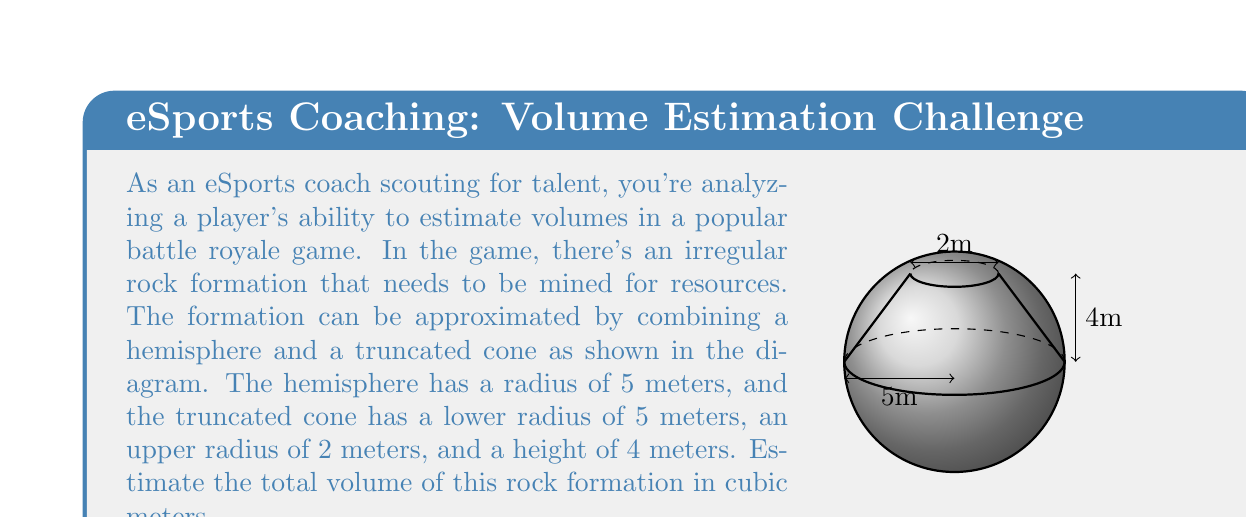Can you answer this question? To estimate the total volume of the rock formation, we need to calculate the volumes of the hemisphere and the truncated cone separately, then add them together.

1. Volume of the hemisphere:
   The formula for the volume of a hemisphere is:
   $$V_{hemisphere} = \frac{2}{3}\pi r^3$$
   Where $r$ is the radius.
   $$V_{hemisphere} = \frac{2}{3}\pi (5)^3 = \frac{250}{3}\pi \approx 261.80 \text{ m}^3$$

2. Volume of the truncated cone:
   The formula for the volume of a truncated cone is:
   $$V_{truncated cone} = \frac{1}{3}\pi h(R^2 + r^2 + Rr)$$
   Where $h$ is the height, $R$ is the radius of the base, and $r$ is the radius of the top.
   $$V_{truncated cone} = \frac{1}{3}\pi (4)(5^2 + 2^2 + 5 \cdot 2)$$
   $$= \frac{4\pi}{3}(25 + 4 + 10) = \frac{156\pi}{3} \approx 163.36 \text{ m}^3$$

3. Total volume:
   $$V_{total} = V_{hemisphere} + V_{truncated cone}$$
   $$= \frac{250}{3}\pi + \frac{156\pi}{3} = \frac{406\pi}{3} \approx 425.16 \text{ m}^3$$

Therefore, the estimated total volume of the rock formation is approximately 425.16 cubic meters.
Answer: 425.16 m³ 